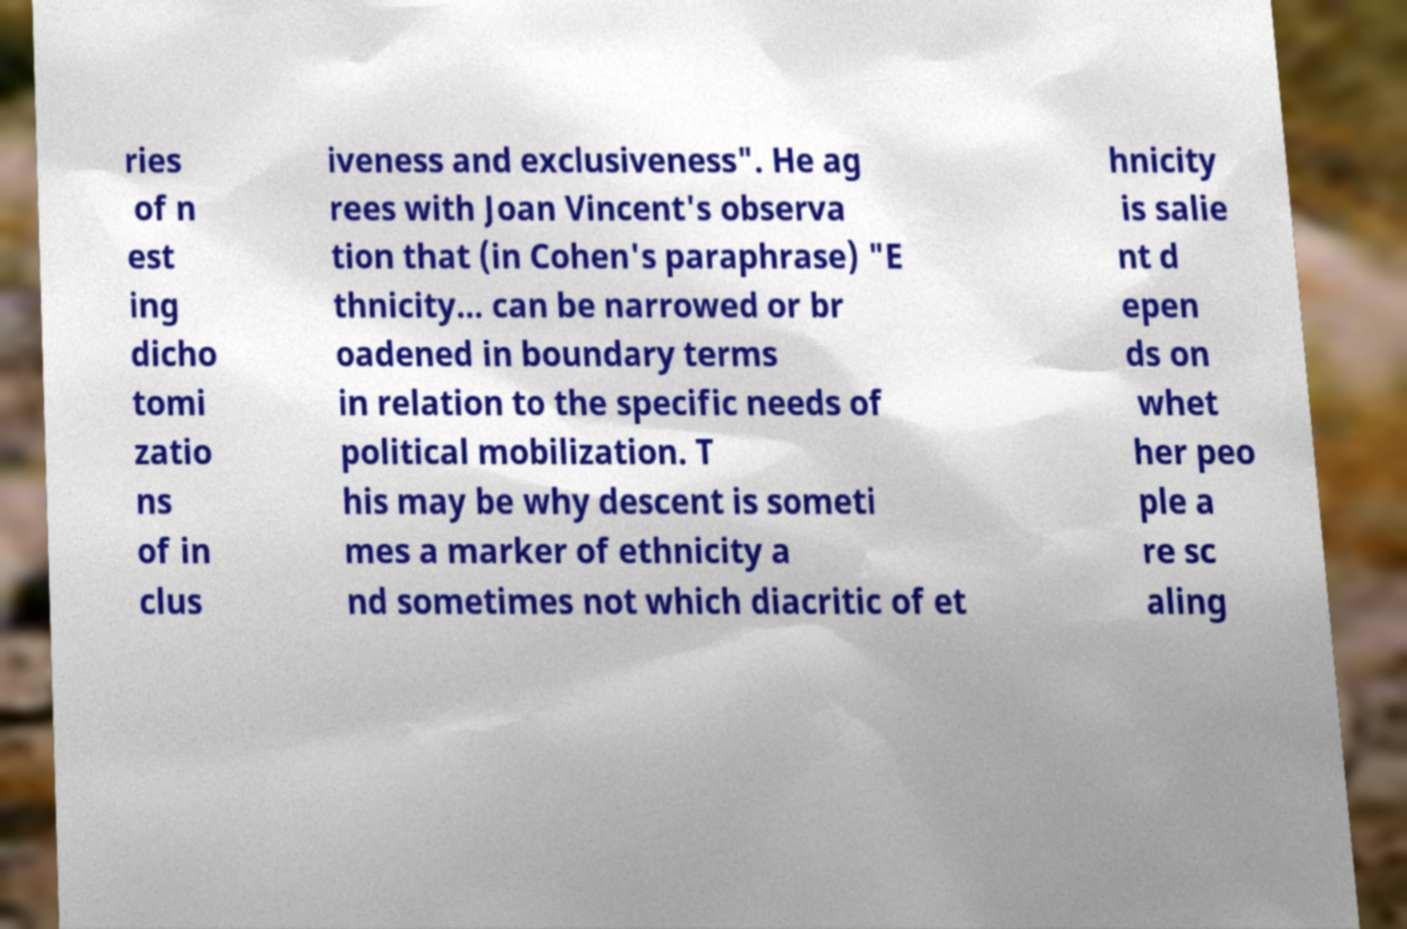Could you extract and type out the text from this image? ries of n est ing dicho tomi zatio ns of in clus iveness and exclusiveness". He ag rees with Joan Vincent's observa tion that (in Cohen's paraphrase) "E thnicity... can be narrowed or br oadened in boundary terms in relation to the specific needs of political mobilization. T his may be why descent is someti mes a marker of ethnicity a nd sometimes not which diacritic of et hnicity is salie nt d epen ds on whet her peo ple a re sc aling 